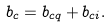<formula> <loc_0><loc_0><loc_500><loc_500>b _ { c } = b _ { c q } + b _ { c i } .</formula> 